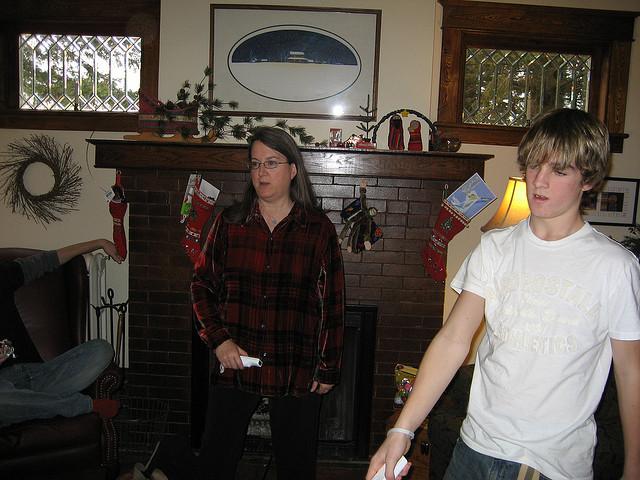What holiday might this be?
Quick response, please. Christmas. What is the boy holding?
Be succinct. Wii remote. What are the people's emotions?
Answer briefly. Sad. What is the brand of the contraption on the left?
Be succinct. Nintendo. Is everyone standing upright in this picture?
Give a very brief answer. Yes. What are they holding?
Give a very brief answer. Wii remotes. What creature is depicted on the woman's sweater?
Concise answer only. Plaid. What kind of glass is in the window frames?
Keep it brief. Stained. 